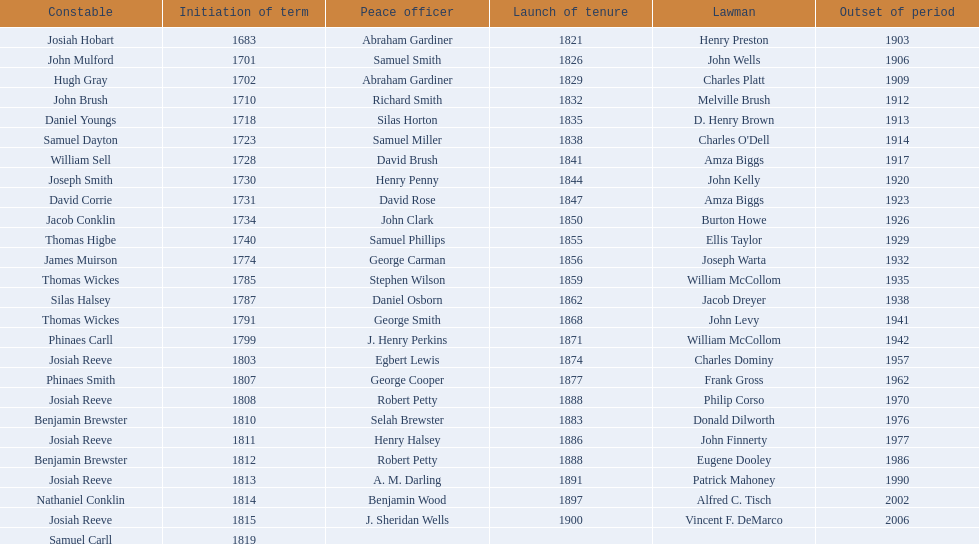How many sheriff's have the last name biggs? 1. 